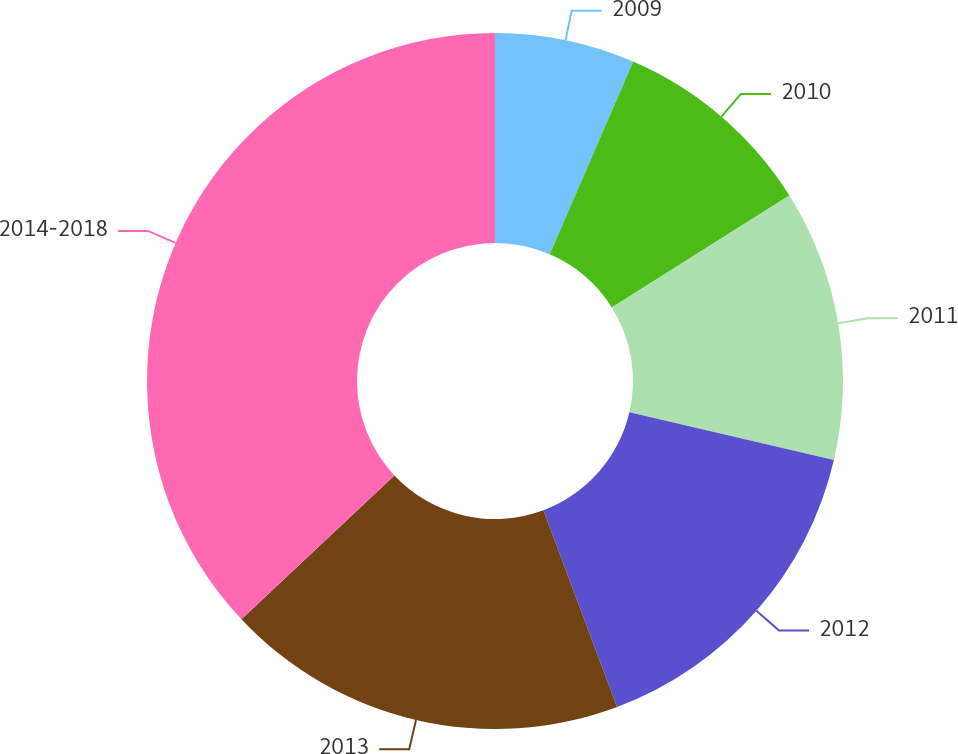<chart> <loc_0><loc_0><loc_500><loc_500><pie_chart><fcel>2009<fcel>2010<fcel>2011<fcel>2012<fcel>2013<fcel>2014-2018<nl><fcel>6.5%<fcel>9.55%<fcel>12.6%<fcel>15.65%<fcel>18.7%<fcel>37.01%<nl></chart> 